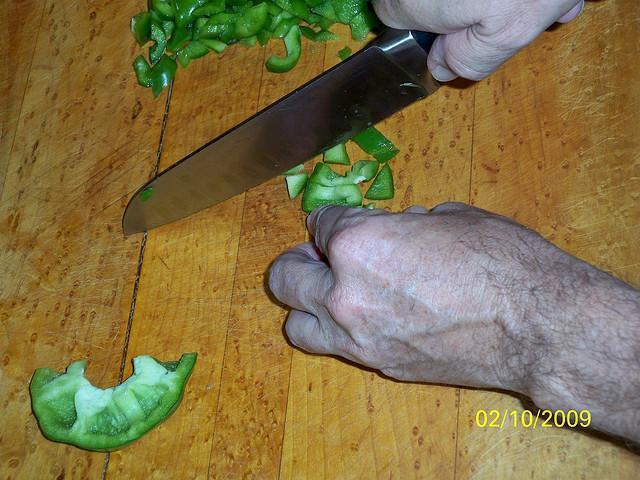How many knives can be seen?
Give a very brief answer. 1. How many giraffes are there?
Give a very brief answer. 0. 